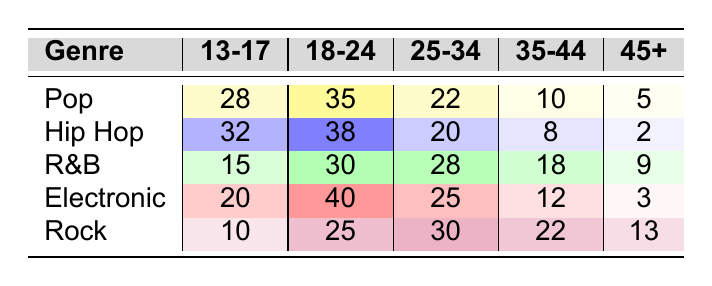What is the number of fans aged 13-17 who prefer Hip Hop? According to the table, there are 32 fans in the age group 13-17 who prefer Hip Hop.
Answer: 32 Which genre has the most fans aged 18-24? In the table, Electronic has the highest count of 40 fans in the age group 18-24.
Answer: Electronic What is the total number of fans in the age group 25-34 across all genres? By adding the counts from the 25-34 age group, we get (22 + 20 + 28 + 25 + 30) = 125 fans.
Answer: 125 Is there a genre that has more fans aged 35-44 than R&B? R&B has 18 fans aged 35-44. Checking the other genres: Pop (10), Hip Hop (8), Electronic (12), Rock (22). Rock is the only genre with more fans aged 35-44 than R&B.
Answer: Yes What is the difference in the number of fans aged 45+ between Pop and Rock? Pop has 5 fans aged 45+, while Rock has 13. The difference is calculated as (13 - 5) = 8 fans.
Answer: 8 Which age group has the lowest number of fans for the genre R&B? Looking at the R&B row, the age group 13-17 has the lowest count, which is 15 fans.
Answer: 13-17 What is the average number of fans aged 18-24 across all genres? The counts for 18-24 are (35 + 38 + 30 + 40 + 25) = 168. There are 5 genres, so the average is (168 / 5) = 33.6, which rounds to 34 when considering whole fans.
Answer: 34 Are there more fans aged 13-17 in Electronic than in Rock? Electronic has 20 fans aged 13-17, while Rock has 10. So yes, there are more fans aged 13-17 in Electronic.
Answer: Yes Which genre has the least fans aged 45+? The genre with the least fans aged 45+ is Hip Hop, with just 2 fans in that age group.
Answer: Hip Hop What is the total number of fans aged 18-24 for all genres combined? Adding the fans aged 18-24 gives us (35 + 38 + 30 + 40 + 25) = 168 fans in total for this age group.
Answer: 168 